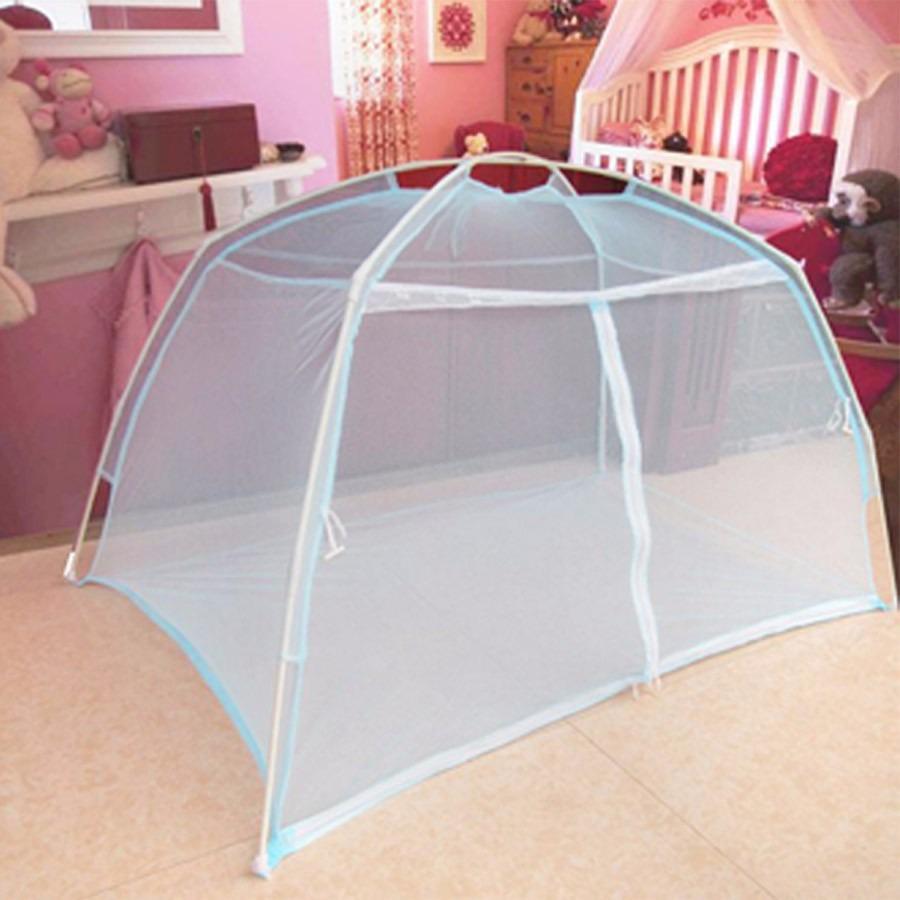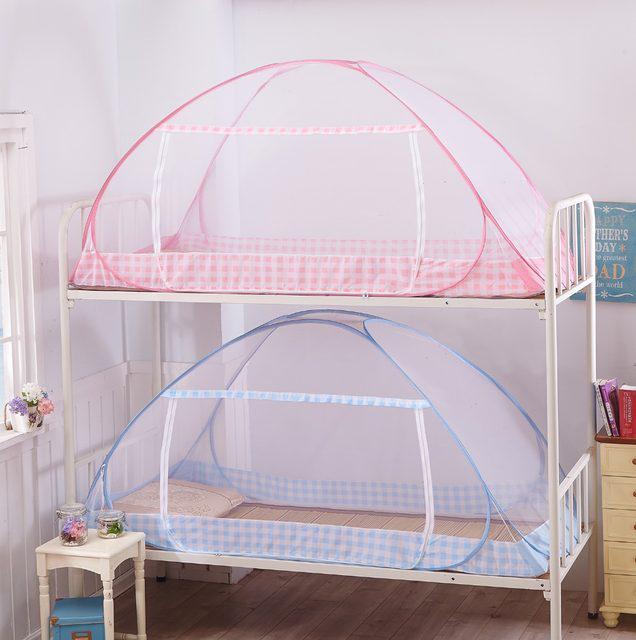The first image is the image on the left, the second image is the image on the right. Analyze the images presented: Is the assertion "There are two tent canopies with at least one with blue trim that has a pattern around the bottom of the tent." valid? Answer yes or no. No. The first image is the image on the left, the second image is the image on the right. Assess this claim about the two images: "In the right image exactly one net has a cloth trim on the bottom.". Correct or not? Answer yes or no. No. 